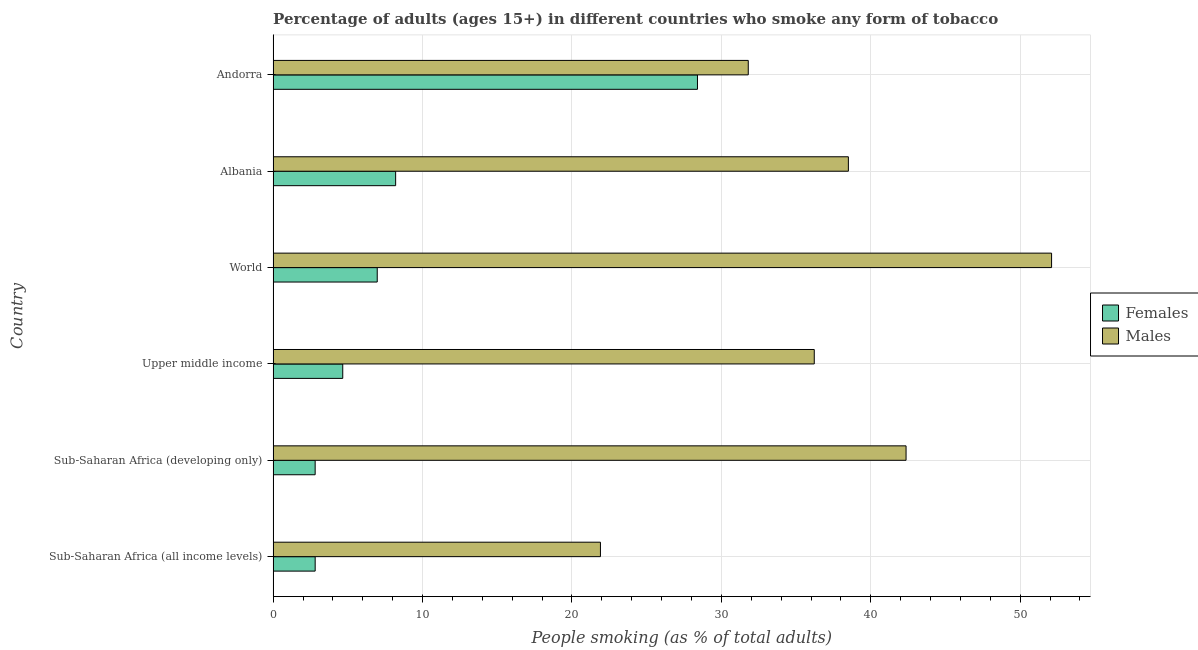How many different coloured bars are there?
Your response must be concise. 2. How many bars are there on the 4th tick from the bottom?
Your answer should be very brief. 2. What is the label of the 2nd group of bars from the top?
Ensure brevity in your answer.  Albania. What is the percentage of males who smoke in World?
Give a very brief answer. 52.1. Across all countries, what is the maximum percentage of males who smoke?
Provide a short and direct response. 52.1. Across all countries, what is the minimum percentage of males who smoke?
Give a very brief answer. 21.91. In which country was the percentage of females who smoke maximum?
Offer a very short reply. Andorra. In which country was the percentage of males who smoke minimum?
Ensure brevity in your answer.  Sub-Saharan Africa (all income levels). What is the total percentage of females who smoke in the graph?
Offer a very short reply. 53.86. What is the difference between the percentage of males who smoke in Andorra and that in Sub-Saharan Africa (all income levels)?
Provide a short and direct response. 9.89. What is the difference between the percentage of males who smoke in World and the percentage of females who smoke in Albania?
Make the answer very short. 43.9. What is the average percentage of males who smoke per country?
Provide a succinct answer. 37.15. What is the difference between the percentage of males who smoke and percentage of females who smoke in Sub-Saharan Africa (all income levels)?
Your answer should be very brief. 19.09. What is the ratio of the percentage of males who smoke in Andorra to that in World?
Your response must be concise. 0.61. Is the percentage of males who smoke in Sub-Saharan Africa (developing only) less than that in World?
Offer a very short reply. Yes. What is the difference between the highest and the second highest percentage of females who smoke?
Your answer should be very brief. 20.2. What is the difference between the highest and the lowest percentage of females who smoke?
Provide a succinct answer. 25.59. Is the sum of the percentage of males who smoke in Albania and World greater than the maximum percentage of females who smoke across all countries?
Your answer should be very brief. Yes. What does the 1st bar from the top in Albania represents?
Keep it short and to the point. Males. What does the 2nd bar from the bottom in World represents?
Your answer should be compact. Males. How many countries are there in the graph?
Your response must be concise. 6. What is the difference between two consecutive major ticks on the X-axis?
Give a very brief answer. 10. Does the graph contain grids?
Offer a very short reply. Yes. Where does the legend appear in the graph?
Your answer should be very brief. Center right. What is the title of the graph?
Your answer should be compact. Percentage of adults (ages 15+) in different countries who smoke any form of tobacco. What is the label or title of the X-axis?
Offer a terse response. People smoking (as % of total adults). What is the People smoking (as % of total adults) of Females in Sub-Saharan Africa (all income levels)?
Your answer should be very brief. 2.81. What is the People smoking (as % of total adults) of Males in Sub-Saharan Africa (all income levels)?
Ensure brevity in your answer.  21.91. What is the People smoking (as % of total adults) of Females in Sub-Saharan Africa (developing only)?
Ensure brevity in your answer.  2.81. What is the People smoking (as % of total adults) of Males in Sub-Saharan Africa (developing only)?
Your answer should be very brief. 42.36. What is the People smoking (as % of total adults) of Females in Upper middle income?
Provide a succinct answer. 4.66. What is the People smoking (as % of total adults) of Males in Upper middle income?
Provide a succinct answer. 36.22. What is the People smoking (as % of total adults) in Females in World?
Your answer should be very brief. 6.97. What is the People smoking (as % of total adults) of Males in World?
Keep it short and to the point. 52.1. What is the People smoking (as % of total adults) of Males in Albania?
Provide a short and direct response. 38.5. What is the People smoking (as % of total adults) in Females in Andorra?
Your response must be concise. 28.4. What is the People smoking (as % of total adults) of Males in Andorra?
Give a very brief answer. 31.8. Across all countries, what is the maximum People smoking (as % of total adults) in Females?
Make the answer very short. 28.4. Across all countries, what is the maximum People smoking (as % of total adults) of Males?
Provide a succinct answer. 52.1. Across all countries, what is the minimum People smoking (as % of total adults) of Females?
Ensure brevity in your answer.  2.81. Across all countries, what is the minimum People smoking (as % of total adults) in Males?
Your response must be concise. 21.91. What is the total People smoking (as % of total adults) in Females in the graph?
Ensure brevity in your answer.  53.86. What is the total People smoking (as % of total adults) in Males in the graph?
Offer a terse response. 222.88. What is the difference between the People smoking (as % of total adults) of Females in Sub-Saharan Africa (all income levels) and that in Sub-Saharan Africa (developing only)?
Offer a terse response. 0. What is the difference between the People smoking (as % of total adults) of Males in Sub-Saharan Africa (all income levels) and that in Sub-Saharan Africa (developing only)?
Offer a terse response. -20.45. What is the difference between the People smoking (as % of total adults) of Females in Sub-Saharan Africa (all income levels) and that in Upper middle income?
Give a very brief answer. -1.85. What is the difference between the People smoking (as % of total adults) of Males in Sub-Saharan Africa (all income levels) and that in Upper middle income?
Your answer should be compact. -14.31. What is the difference between the People smoking (as % of total adults) of Females in Sub-Saharan Africa (all income levels) and that in World?
Give a very brief answer. -4.15. What is the difference between the People smoking (as % of total adults) of Males in Sub-Saharan Africa (all income levels) and that in World?
Your answer should be very brief. -30.19. What is the difference between the People smoking (as % of total adults) of Females in Sub-Saharan Africa (all income levels) and that in Albania?
Offer a very short reply. -5.39. What is the difference between the People smoking (as % of total adults) of Males in Sub-Saharan Africa (all income levels) and that in Albania?
Offer a terse response. -16.59. What is the difference between the People smoking (as % of total adults) of Females in Sub-Saharan Africa (all income levels) and that in Andorra?
Make the answer very short. -25.59. What is the difference between the People smoking (as % of total adults) in Males in Sub-Saharan Africa (all income levels) and that in Andorra?
Give a very brief answer. -9.89. What is the difference between the People smoking (as % of total adults) in Females in Sub-Saharan Africa (developing only) and that in Upper middle income?
Your answer should be compact. -1.85. What is the difference between the People smoking (as % of total adults) of Males in Sub-Saharan Africa (developing only) and that in Upper middle income?
Offer a very short reply. 6.14. What is the difference between the People smoking (as % of total adults) of Females in Sub-Saharan Africa (developing only) and that in World?
Your response must be concise. -4.15. What is the difference between the People smoking (as % of total adults) in Males in Sub-Saharan Africa (developing only) and that in World?
Provide a succinct answer. -9.74. What is the difference between the People smoking (as % of total adults) of Females in Sub-Saharan Africa (developing only) and that in Albania?
Provide a short and direct response. -5.39. What is the difference between the People smoking (as % of total adults) in Males in Sub-Saharan Africa (developing only) and that in Albania?
Offer a terse response. 3.86. What is the difference between the People smoking (as % of total adults) in Females in Sub-Saharan Africa (developing only) and that in Andorra?
Provide a succinct answer. -25.59. What is the difference between the People smoking (as % of total adults) of Males in Sub-Saharan Africa (developing only) and that in Andorra?
Provide a succinct answer. 10.56. What is the difference between the People smoking (as % of total adults) in Females in Upper middle income and that in World?
Provide a succinct answer. -2.31. What is the difference between the People smoking (as % of total adults) in Males in Upper middle income and that in World?
Provide a short and direct response. -15.88. What is the difference between the People smoking (as % of total adults) in Females in Upper middle income and that in Albania?
Offer a terse response. -3.54. What is the difference between the People smoking (as % of total adults) of Males in Upper middle income and that in Albania?
Offer a terse response. -2.28. What is the difference between the People smoking (as % of total adults) in Females in Upper middle income and that in Andorra?
Provide a succinct answer. -23.74. What is the difference between the People smoking (as % of total adults) in Males in Upper middle income and that in Andorra?
Make the answer very short. 4.42. What is the difference between the People smoking (as % of total adults) in Females in World and that in Albania?
Make the answer very short. -1.23. What is the difference between the People smoking (as % of total adults) in Females in World and that in Andorra?
Offer a terse response. -21.43. What is the difference between the People smoking (as % of total adults) in Males in World and that in Andorra?
Provide a short and direct response. 20.3. What is the difference between the People smoking (as % of total adults) of Females in Albania and that in Andorra?
Provide a succinct answer. -20.2. What is the difference between the People smoking (as % of total adults) in Females in Sub-Saharan Africa (all income levels) and the People smoking (as % of total adults) in Males in Sub-Saharan Africa (developing only)?
Keep it short and to the point. -39.55. What is the difference between the People smoking (as % of total adults) of Females in Sub-Saharan Africa (all income levels) and the People smoking (as % of total adults) of Males in Upper middle income?
Ensure brevity in your answer.  -33.4. What is the difference between the People smoking (as % of total adults) in Females in Sub-Saharan Africa (all income levels) and the People smoking (as % of total adults) in Males in World?
Your answer should be compact. -49.29. What is the difference between the People smoking (as % of total adults) of Females in Sub-Saharan Africa (all income levels) and the People smoking (as % of total adults) of Males in Albania?
Offer a terse response. -35.69. What is the difference between the People smoking (as % of total adults) in Females in Sub-Saharan Africa (all income levels) and the People smoking (as % of total adults) in Males in Andorra?
Ensure brevity in your answer.  -28.99. What is the difference between the People smoking (as % of total adults) in Females in Sub-Saharan Africa (developing only) and the People smoking (as % of total adults) in Males in Upper middle income?
Keep it short and to the point. -33.4. What is the difference between the People smoking (as % of total adults) in Females in Sub-Saharan Africa (developing only) and the People smoking (as % of total adults) in Males in World?
Offer a terse response. -49.29. What is the difference between the People smoking (as % of total adults) of Females in Sub-Saharan Africa (developing only) and the People smoking (as % of total adults) of Males in Albania?
Your answer should be very brief. -35.69. What is the difference between the People smoking (as % of total adults) in Females in Sub-Saharan Africa (developing only) and the People smoking (as % of total adults) in Males in Andorra?
Keep it short and to the point. -28.99. What is the difference between the People smoking (as % of total adults) of Females in Upper middle income and the People smoking (as % of total adults) of Males in World?
Give a very brief answer. -47.44. What is the difference between the People smoking (as % of total adults) of Females in Upper middle income and the People smoking (as % of total adults) of Males in Albania?
Your answer should be very brief. -33.84. What is the difference between the People smoking (as % of total adults) in Females in Upper middle income and the People smoking (as % of total adults) in Males in Andorra?
Offer a very short reply. -27.14. What is the difference between the People smoking (as % of total adults) in Females in World and the People smoking (as % of total adults) in Males in Albania?
Give a very brief answer. -31.53. What is the difference between the People smoking (as % of total adults) of Females in World and the People smoking (as % of total adults) of Males in Andorra?
Provide a succinct answer. -24.83. What is the difference between the People smoking (as % of total adults) in Females in Albania and the People smoking (as % of total adults) in Males in Andorra?
Give a very brief answer. -23.6. What is the average People smoking (as % of total adults) in Females per country?
Give a very brief answer. 8.98. What is the average People smoking (as % of total adults) of Males per country?
Give a very brief answer. 37.15. What is the difference between the People smoking (as % of total adults) of Females and People smoking (as % of total adults) of Males in Sub-Saharan Africa (all income levels)?
Your answer should be very brief. -19.09. What is the difference between the People smoking (as % of total adults) of Females and People smoking (as % of total adults) of Males in Sub-Saharan Africa (developing only)?
Provide a succinct answer. -39.55. What is the difference between the People smoking (as % of total adults) in Females and People smoking (as % of total adults) in Males in Upper middle income?
Your answer should be compact. -31.56. What is the difference between the People smoking (as % of total adults) in Females and People smoking (as % of total adults) in Males in World?
Your answer should be compact. -45.13. What is the difference between the People smoking (as % of total adults) in Females and People smoking (as % of total adults) in Males in Albania?
Offer a very short reply. -30.3. What is the ratio of the People smoking (as % of total adults) of Males in Sub-Saharan Africa (all income levels) to that in Sub-Saharan Africa (developing only)?
Provide a succinct answer. 0.52. What is the ratio of the People smoking (as % of total adults) of Females in Sub-Saharan Africa (all income levels) to that in Upper middle income?
Provide a short and direct response. 0.6. What is the ratio of the People smoking (as % of total adults) of Males in Sub-Saharan Africa (all income levels) to that in Upper middle income?
Offer a very short reply. 0.6. What is the ratio of the People smoking (as % of total adults) in Females in Sub-Saharan Africa (all income levels) to that in World?
Provide a short and direct response. 0.4. What is the ratio of the People smoking (as % of total adults) of Males in Sub-Saharan Africa (all income levels) to that in World?
Make the answer very short. 0.42. What is the ratio of the People smoking (as % of total adults) in Females in Sub-Saharan Africa (all income levels) to that in Albania?
Make the answer very short. 0.34. What is the ratio of the People smoking (as % of total adults) in Males in Sub-Saharan Africa (all income levels) to that in Albania?
Provide a succinct answer. 0.57. What is the ratio of the People smoking (as % of total adults) of Females in Sub-Saharan Africa (all income levels) to that in Andorra?
Your answer should be very brief. 0.1. What is the ratio of the People smoking (as % of total adults) in Males in Sub-Saharan Africa (all income levels) to that in Andorra?
Your answer should be compact. 0.69. What is the ratio of the People smoking (as % of total adults) of Females in Sub-Saharan Africa (developing only) to that in Upper middle income?
Your answer should be very brief. 0.6. What is the ratio of the People smoking (as % of total adults) of Males in Sub-Saharan Africa (developing only) to that in Upper middle income?
Make the answer very short. 1.17. What is the ratio of the People smoking (as % of total adults) of Females in Sub-Saharan Africa (developing only) to that in World?
Offer a very short reply. 0.4. What is the ratio of the People smoking (as % of total adults) of Males in Sub-Saharan Africa (developing only) to that in World?
Provide a succinct answer. 0.81. What is the ratio of the People smoking (as % of total adults) of Females in Sub-Saharan Africa (developing only) to that in Albania?
Your response must be concise. 0.34. What is the ratio of the People smoking (as % of total adults) in Males in Sub-Saharan Africa (developing only) to that in Albania?
Provide a short and direct response. 1.1. What is the ratio of the People smoking (as % of total adults) in Females in Sub-Saharan Africa (developing only) to that in Andorra?
Ensure brevity in your answer.  0.1. What is the ratio of the People smoking (as % of total adults) in Males in Sub-Saharan Africa (developing only) to that in Andorra?
Keep it short and to the point. 1.33. What is the ratio of the People smoking (as % of total adults) of Females in Upper middle income to that in World?
Give a very brief answer. 0.67. What is the ratio of the People smoking (as % of total adults) in Males in Upper middle income to that in World?
Your response must be concise. 0.7. What is the ratio of the People smoking (as % of total adults) of Females in Upper middle income to that in Albania?
Keep it short and to the point. 0.57. What is the ratio of the People smoking (as % of total adults) in Males in Upper middle income to that in Albania?
Your answer should be very brief. 0.94. What is the ratio of the People smoking (as % of total adults) in Females in Upper middle income to that in Andorra?
Keep it short and to the point. 0.16. What is the ratio of the People smoking (as % of total adults) of Males in Upper middle income to that in Andorra?
Keep it short and to the point. 1.14. What is the ratio of the People smoking (as % of total adults) of Females in World to that in Albania?
Ensure brevity in your answer.  0.85. What is the ratio of the People smoking (as % of total adults) of Males in World to that in Albania?
Your response must be concise. 1.35. What is the ratio of the People smoking (as % of total adults) in Females in World to that in Andorra?
Ensure brevity in your answer.  0.25. What is the ratio of the People smoking (as % of total adults) of Males in World to that in Andorra?
Give a very brief answer. 1.64. What is the ratio of the People smoking (as % of total adults) in Females in Albania to that in Andorra?
Provide a succinct answer. 0.29. What is the ratio of the People smoking (as % of total adults) of Males in Albania to that in Andorra?
Provide a short and direct response. 1.21. What is the difference between the highest and the second highest People smoking (as % of total adults) of Females?
Keep it short and to the point. 20.2. What is the difference between the highest and the second highest People smoking (as % of total adults) in Males?
Provide a succinct answer. 9.74. What is the difference between the highest and the lowest People smoking (as % of total adults) of Females?
Your answer should be very brief. 25.59. What is the difference between the highest and the lowest People smoking (as % of total adults) in Males?
Provide a short and direct response. 30.19. 